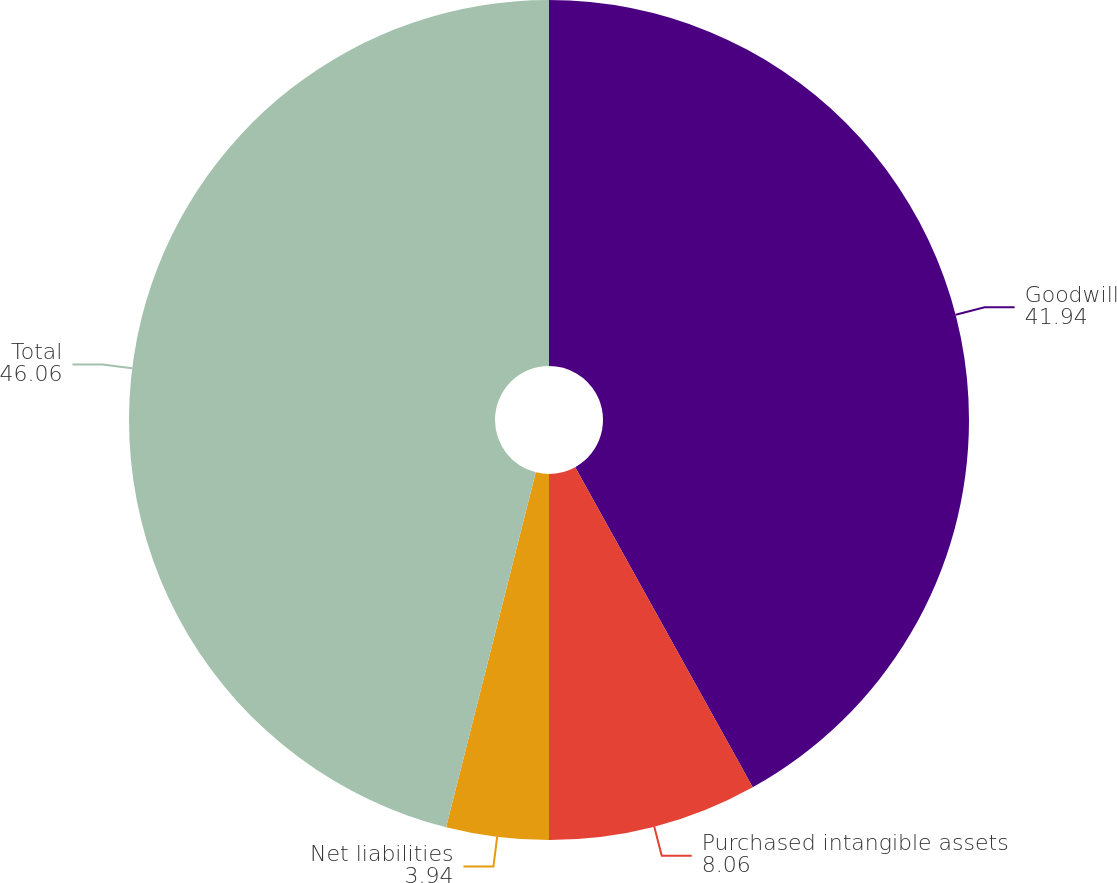Convert chart to OTSL. <chart><loc_0><loc_0><loc_500><loc_500><pie_chart><fcel>Goodwill<fcel>Purchased intangible assets<fcel>Net liabilities<fcel>Total<nl><fcel>41.94%<fcel>8.06%<fcel>3.94%<fcel>46.06%<nl></chart> 